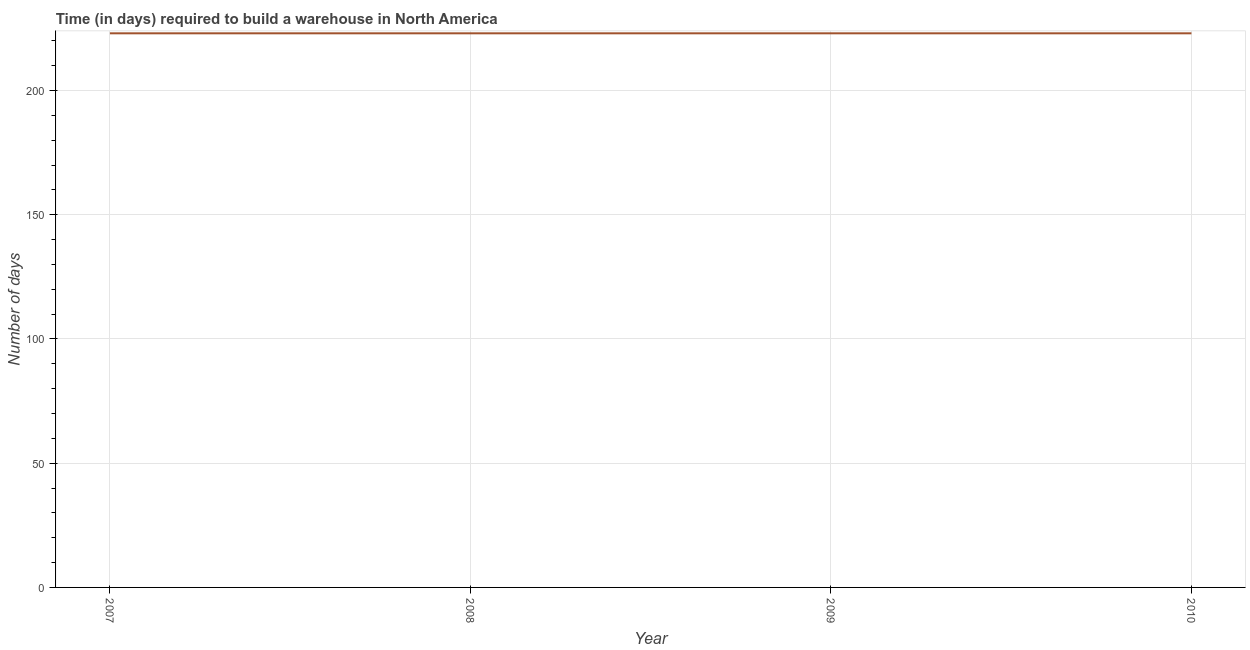What is the time required to build a warehouse in 2010?
Offer a terse response. 223. Across all years, what is the maximum time required to build a warehouse?
Your answer should be very brief. 223. Across all years, what is the minimum time required to build a warehouse?
Give a very brief answer. 223. In which year was the time required to build a warehouse minimum?
Your answer should be very brief. 2007. What is the sum of the time required to build a warehouse?
Offer a terse response. 892. What is the difference between the time required to build a warehouse in 2008 and 2009?
Offer a terse response. 0. What is the average time required to build a warehouse per year?
Offer a terse response. 223. What is the median time required to build a warehouse?
Make the answer very short. 223. In how many years, is the time required to build a warehouse greater than 20 days?
Your answer should be compact. 4. Do a majority of the years between 2007 and 2008 (inclusive) have time required to build a warehouse greater than 70 days?
Your answer should be very brief. Yes. Is the sum of the time required to build a warehouse in 2007 and 2009 greater than the maximum time required to build a warehouse across all years?
Keep it short and to the point. Yes. Does the time required to build a warehouse monotonically increase over the years?
Keep it short and to the point. No. How many lines are there?
Offer a terse response. 1. What is the difference between two consecutive major ticks on the Y-axis?
Your response must be concise. 50. Are the values on the major ticks of Y-axis written in scientific E-notation?
Make the answer very short. No. Does the graph contain grids?
Keep it short and to the point. Yes. What is the title of the graph?
Keep it short and to the point. Time (in days) required to build a warehouse in North America. What is the label or title of the Y-axis?
Keep it short and to the point. Number of days. What is the Number of days of 2007?
Provide a succinct answer. 223. What is the Number of days in 2008?
Provide a succinct answer. 223. What is the Number of days of 2009?
Give a very brief answer. 223. What is the Number of days of 2010?
Ensure brevity in your answer.  223. What is the difference between the Number of days in 2007 and 2008?
Your answer should be compact. 0. What is the difference between the Number of days in 2007 and 2010?
Your response must be concise. 0. What is the difference between the Number of days in 2008 and 2010?
Your response must be concise. 0. What is the ratio of the Number of days in 2009 to that in 2010?
Your answer should be compact. 1. 